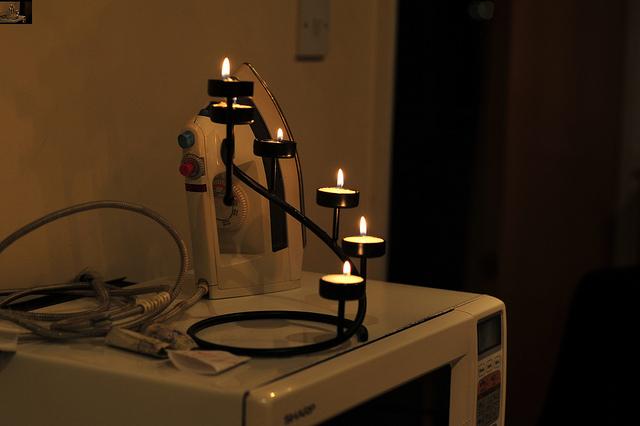What color is the candle holder?
Be succinct. Black. Was this scene displayed during the day?
Answer briefly. No. What is the sculpture of?
Concise answer only. Candles. Are the lights on?
Be succinct. No. Is there an iron on the microwave?
Concise answer only. Yes. What are the holder sculpted to look like?
Answer briefly. Stairs. How many candles are there?
Keep it brief. 6. Is this a microwave?
Answer briefly. Yes. How many candles are on?
Short answer required. 6. Is there a toilet here?
Answer briefly. No. Is this a kitchen?
Concise answer only. Yes. 